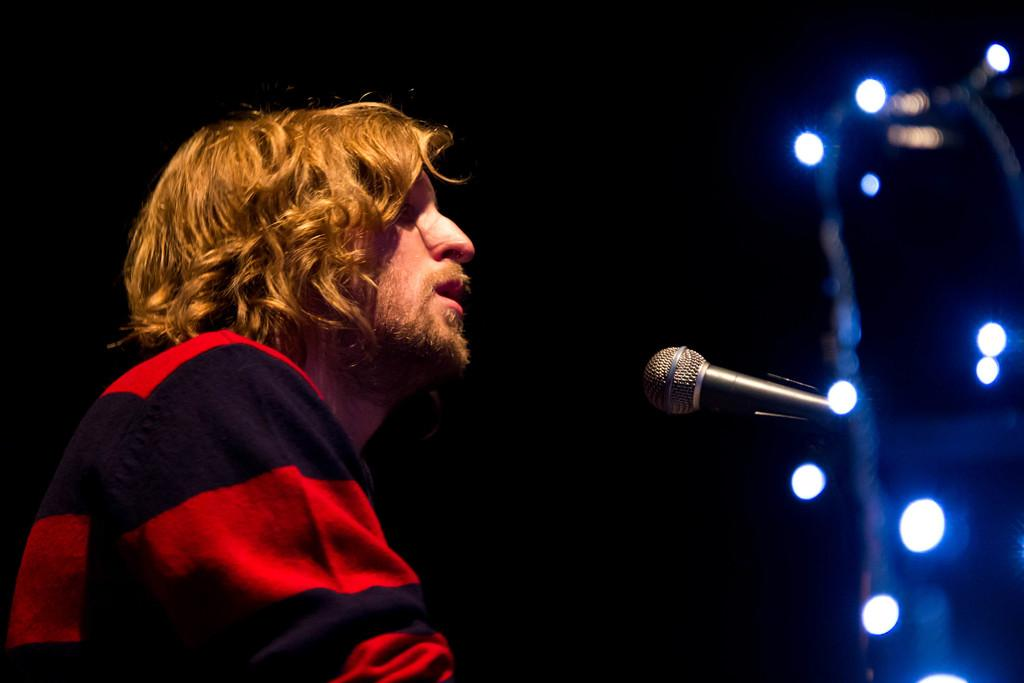What is the person in the image doing? There is a person singing in the image. What object is the person using while singing? There is a microphone in the image. What can be seen in the background of the image? The background of the image is dark. What might be used to illuminate the person or the stage in the image? There are lights in the image. What type of treatment is the person receiving while singing in the image? There is no indication in the image that the person is receiving any treatment while singing. Can you tell me how many trains are visible in the image? There are no trains present in the image. 